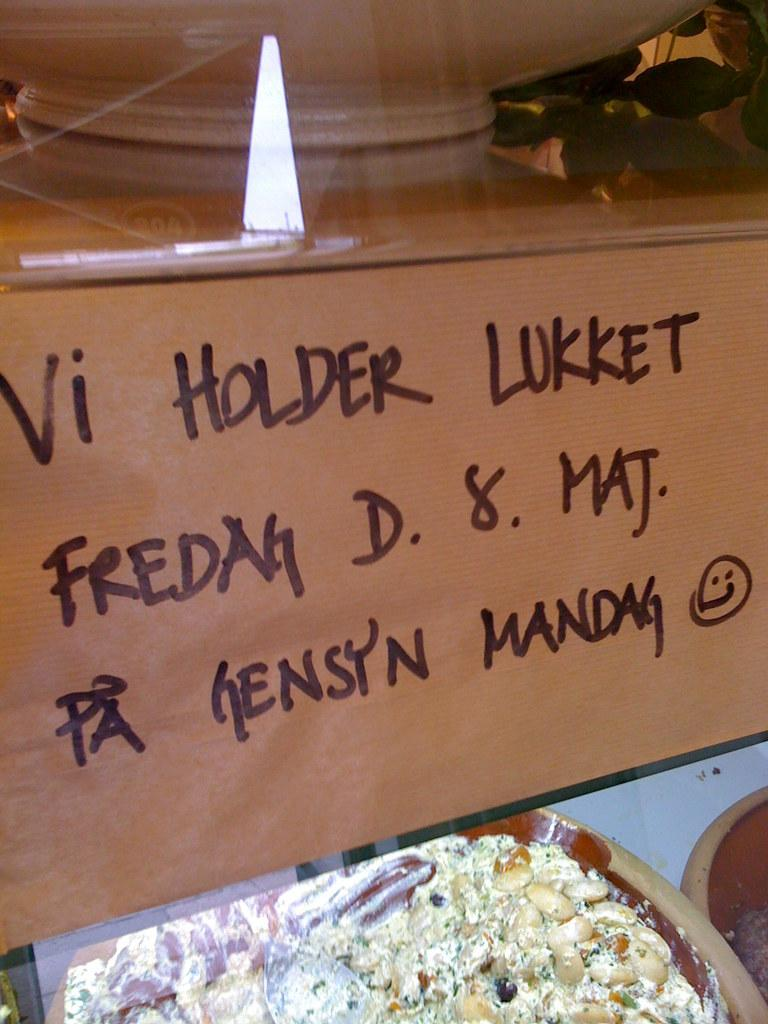What type of containers are present in the image? There are bowls with food in the image. What else can be seen in the image besides the bowls with food? There is a board with text in the image. How many lizards can be seen climbing on the board with text in the image? There are no lizards present in the image. What type of lift is visible in the image? There is no lift present in the image. 